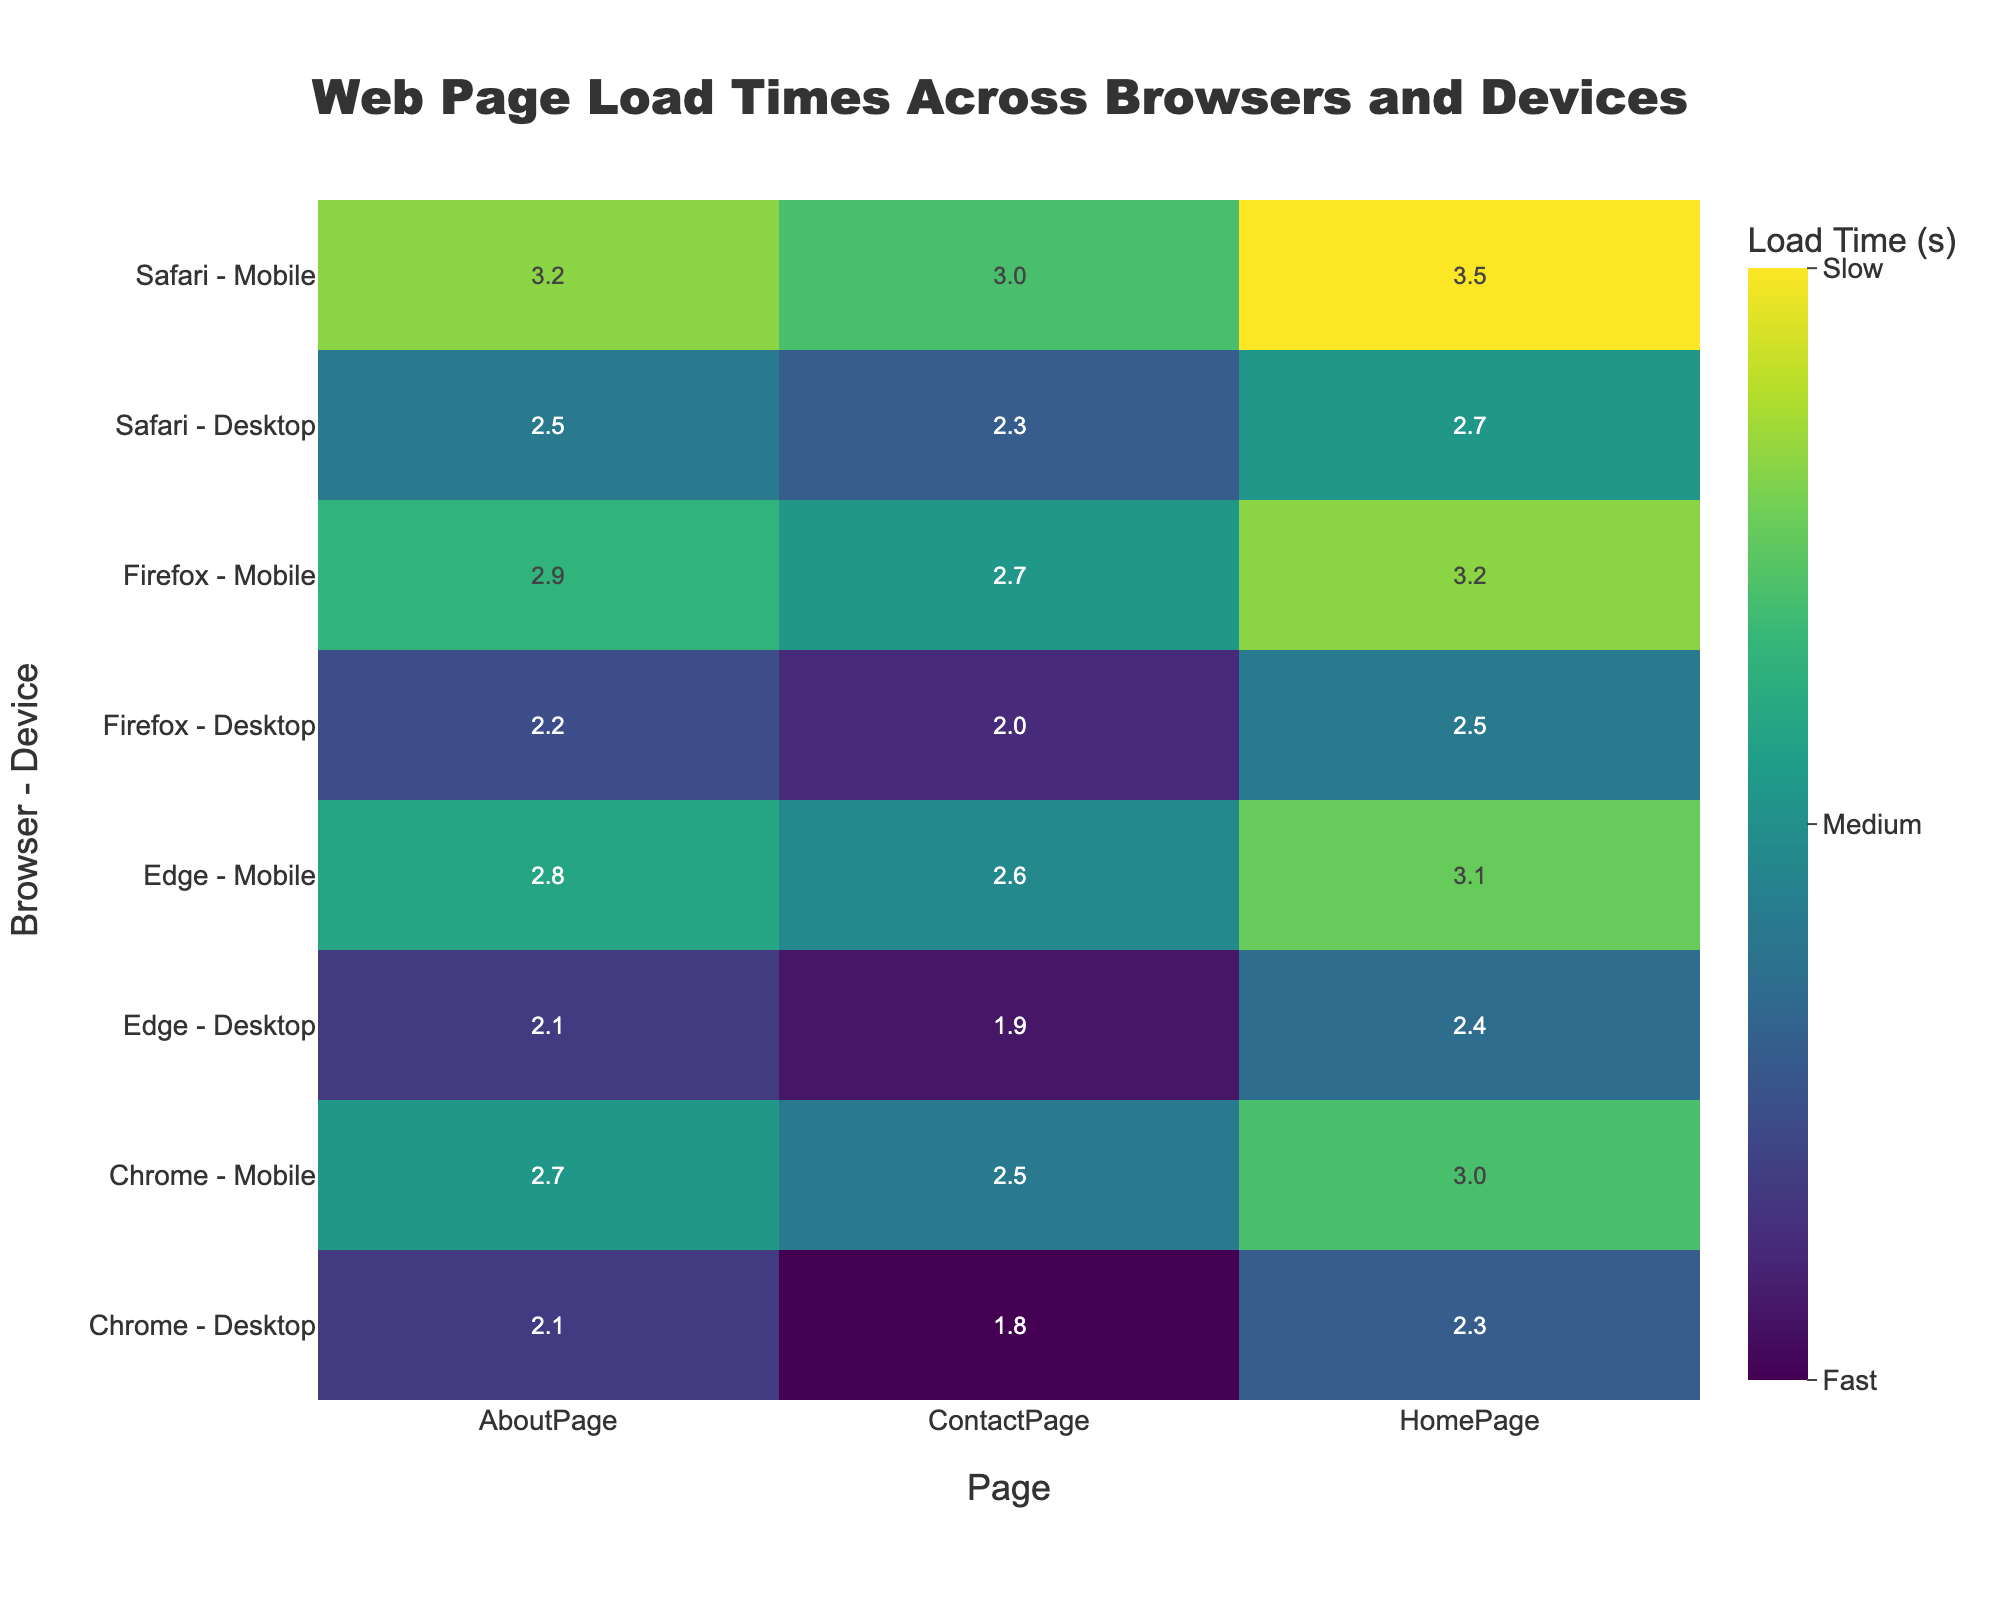What is the title of the heatmap? The title is prominently displayed at the top of the heatmap. It reads 'Web Page Load Times Across Browsers and Devices'.
Answer: Web Page Load Times Across Browsers and Devices Which browser-device combination has the slowest load time for the HomePage? By looking at the heatmap, the highest load time for the HomePage can be observed for the Safari - Mobile combination, indicated by the darkest color on the scale.
Answer: Safari - Mobile What is the load time for the ContactPage on Chrome Desktop? Locate 'Chrome - Desktop' on the y-axis and 'ContactPage' on the x-axis. The intersecting cell displays '1.8', which is the load time.
Answer: 1.8 How do the load times for the AboutPage compare between Firefox and Edge on Mobile devices? Compare the colors of the cells for 'Firefox - Mobile' and 'Edge - Mobile' under the 'AboutPage' column. Firefox - Mobile shows '2.9' and Edge - Mobile shows '2.8', indicating Firefox is slightly slower.
Answer: Firefox is slightly slower Which page has the highest average load time across all browser-device combinations? To determine this, average the load times for each page across different combinations. The 'HomePage' shows higher values than the other two pages, so it has the highest average load time.
Answer: HomePage What is the difference in load time for the ContactPage on Safari Desktop vs. Edge Desktop? Locate the cells for 'Safari - Desktop' and 'Edge - Desktop' for 'ContactPage'. Safari's load time is '2.3' and Edge's is '1.9'. The difference is '2.3 - 1.9 = 0.4'.
Answer: 0.4 Which browser shows a consistent performance between Desktop and Mobile for the AboutPage? Compare the AboutPage cells across Desktop and Mobile for each browser. Edge shows similar values of '2.1' (Desktop) and '2.8' (Mobile), indicating relatively consistent performance.
Answer: Edge On which device does Chrome show the largest variation in load times across different pages? Look at the load times for Chrome on Desktop and Mobile. The variation is larger in Mobile ('3.0', '2.5', '2.7') compared to Desktop ('2.3', '1.8', '2.1').
Answer: Mobile Which combinations fall into the 'Slow' category based on the colorbar ticks? According to the color bar, 'Slow' corresponds to the highest range. Check the cells visually matching this range. 'Safari - Mobile' for the HomePage and others are in this category.
Answer: Safari - Mobile 